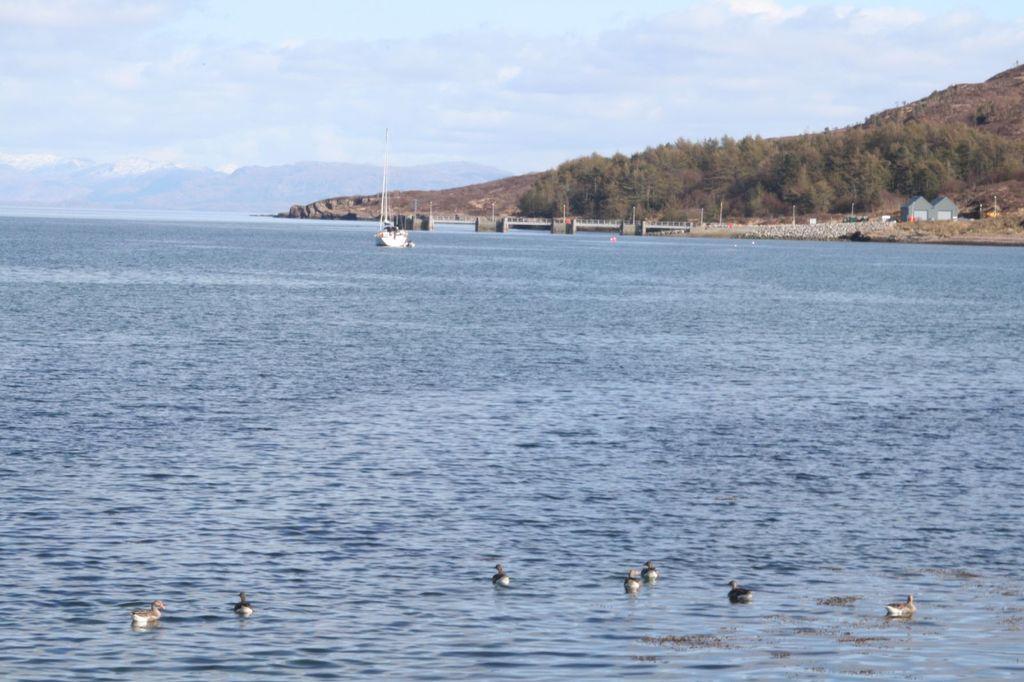Please provide a concise description of this image. In this image I can see the water, few birds which are black, brown and cream in color on the surface of the water , a boat which is white in color on the surface of the water and a bridge. In the background I can see few mountains, few trees, few houses and the sky. 